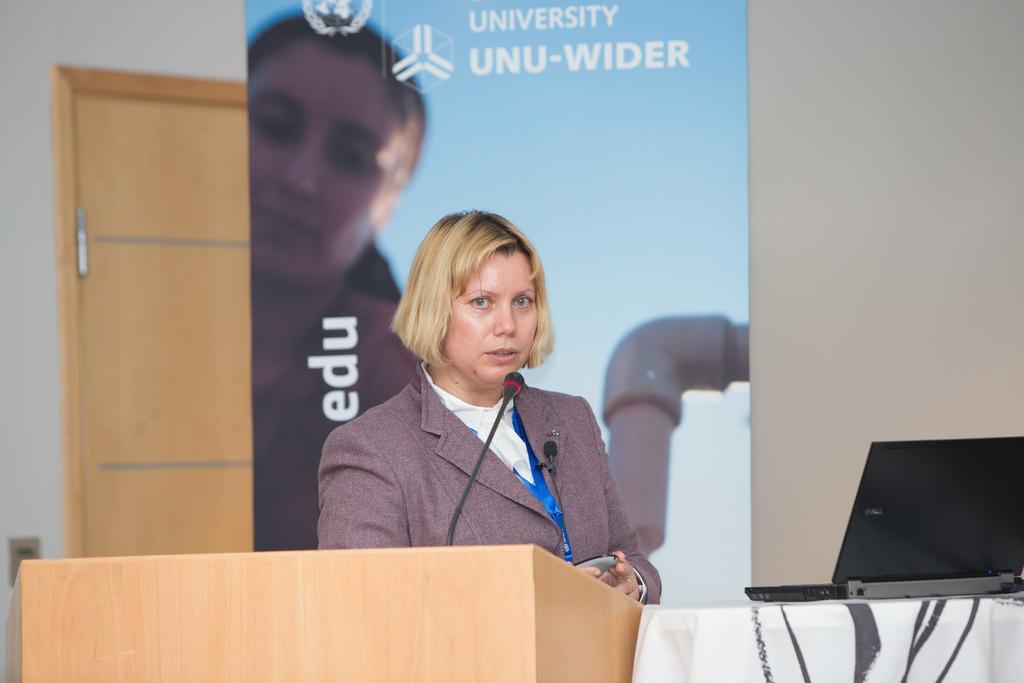Could you give a brief overview of what you see in this image? In this image there is a woman standing and holding an object. On the table there is a mic and a laptop on the other table, behind the woman there is a banner with an image and some text on it, behind the banner there is a door and a wall. 